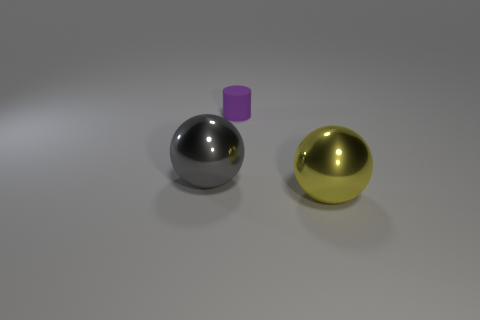Is there any other thing that has the same size as the purple thing?
Offer a terse response. No. What is the shape of the metal thing that is the same size as the gray sphere?
Offer a very short reply. Sphere. There is a big object that is in front of the large gray metallic sphere behind the big yellow ball; how many large shiny balls are on the left side of it?
Ensure brevity in your answer.  1. Are there more gray spheres left of the purple rubber thing than gray metallic objects right of the big yellow metal ball?
Make the answer very short. Yes. What number of other big objects have the same shape as the big yellow thing?
Your answer should be compact. 1. How many things are balls on the right side of the small purple rubber cylinder or shiny spheres that are behind the yellow metal sphere?
Offer a terse response. 2. There is a large ball that is to the right of the big metallic thing behind the big sphere that is right of the large gray ball; what is it made of?
Your answer should be compact. Metal. What is the material of the thing that is both behind the yellow shiny thing and right of the gray metal thing?
Provide a succinct answer. Rubber. Is there a yellow metallic sphere of the same size as the gray object?
Provide a short and direct response. Yes. What number of small purple cylinders are there?
Give a very brief answer. 1. 